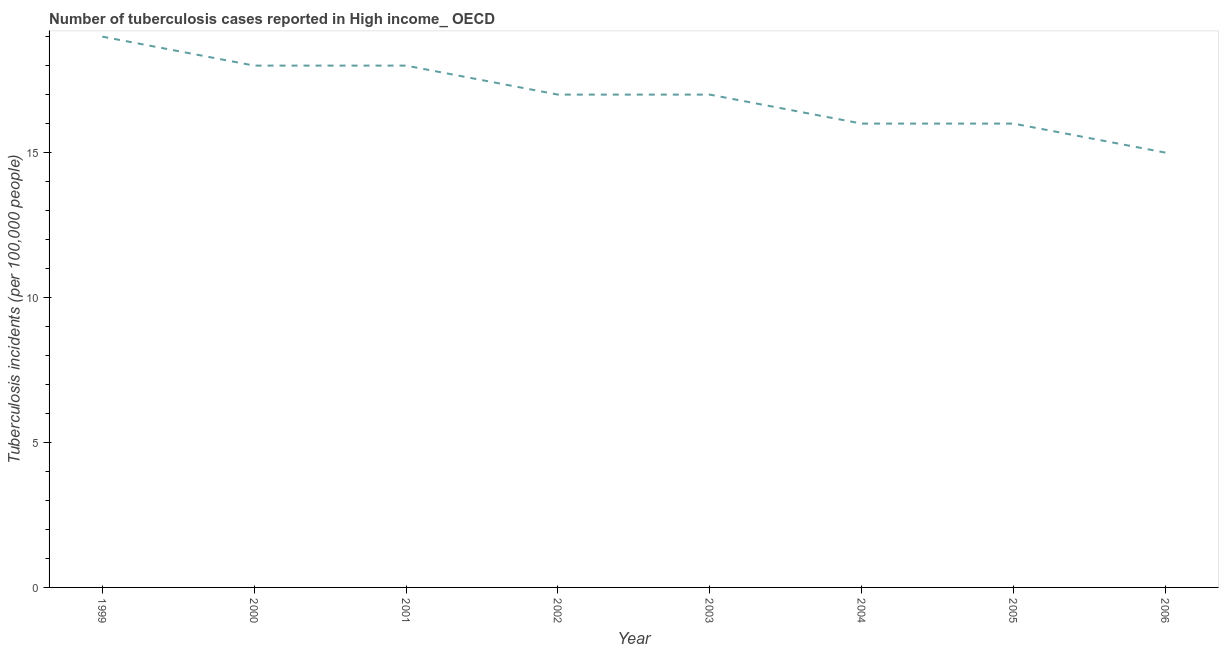What is the number of tuberculosis incidents in 2005?
Keep it short and to the point. 16. Across all years, what is the maximum number of tuberculosis incidents?
Offer a terse response. 19. Across all years, what is the minimum number of tuberculosis incidents?
Offer a very short reply. 15. In which year was the number of tuberculosis incidents maximum?
Make the answer very short. 1999. In which year was the number of tuberculosis incidents minimum?
Give a very brief answer. 2006. What is the sum of the number of tuberculosis incidents?
Offer a very short reply. 136. What is the difference between the number of tuberculosis incidents in 2003 and 2005?
Make the answer very short. 1. Is the difference between the number of tuberculosis incidents in 2004 and 2005 greater than the difference between any two years?
Offer a very short reply. No. What is the difference between the highest and the lowest number of tuberculosis incidents?
Your answer should be very brief. 4. Does the number of tuberculosis incidents monotonically increase over the years?
Provide a succinct answer. No. What is the difference between two consecutive major ticks on the Y-axis?
Make the answer very short. 5. Are the values on the major ticks of Y-axis written in scientific E-notation?
Give a very brief answer. No. Does the graph contain any zero values?
Give a very brief answer. No. What is the title of the graph?
Provide a short and direct response. Number of tuberculosis cases reported in High income_ OECD. What is the label or title of the Y-axis?
Provide a short and direct response. Tuberculosis incidents (per 100,0 people). What is the Tuberculosis incidents (per 100,000 people) in 2002?
Offer a terse response. 17. What is the Tuberculosis incidents (per 100,000 people) of 2003?
Provide a short and direct response. 17. What is the Tuberculosis incidents (per 100,000 people) of 2005?
Provide a succinct answer. 16. What is the difference between the Tuberculosis incidents (per 100,000 people) in 1999 and 2000?
Make the answer very short. 1. What is the difference between the Tuberculosis incidents (per 100,000 people) in 1999 and 2004?
Keep it short and to the point. 3. What is the difference between the Tuberculosis incidents (per 100,000 people) in 1999 and 2005?
Provide a succinct answer. 3. What is the difference between the Tuberculosis incidents (per 100,000 people) in 1999 and 2006?
Give a very brief answer. 4. What is the difference between the Tuberculosis incidents (per 100,000 people) in 2000 and 2001?
Your answer should be very brief. 0. What is the difference between the Tuberculosis incidents (per 100,000 people) in 2000 and 2002?
Ensure brevity in your answer.  1. What is the difference between the Tuberculosis incidents (per 100,000 people) in 2000 and 2003?
Give a very brief answer. 1. What is the difference between the Tuberculosis incidents (per 100,000 people) in 2000 and 2004?
Make the answer very short. 2. What is the difference between the Tuberculosis incidents (per 100,000 people) in 2000 and 2006?
Make the answer very short. 3. What is the difference between the Tuberculosis incidents (per 100,000 people) in 2001 and 2003?
Ensure brevity in your answer.  1. What is the difference between the Tuberculosis incidents (per 100,000 people) in 2001 and 2004?
Offer a terse response. 2. What is the difference between the Tuberculosis incidents (per 100,000 people) in 2001 and 2006?
Your answer should be very brief. 3. What is the difference between the Tuberculosis incidents (per 100,000 people) in 2002 and 2003?
Your answer should be compact. 0. What is the difference between the Tuberculosis incidents (per 100,000 people) in 2002 and 2005?
Ensure brevity in your answer.  1. What is the difference between the Tuberculosis incidents (per 100,000 people) in 2003 and 2005?
Provide a short and direct response. 1. What is the difference between the Tuberculosis incidents (per 100,000 people) in 2003 and 2006?
Make the answer very short. 2. What is the difference between the Tuberculosis incidents (per 100,000 people) in 2004 and 2006?
Make the answer very short. 1. What is the ratio of the Tuberculosis incidents (per 100,000 people) in 1999 to that in 2000?
Your answer should be compact. 1.06. What is the ratio of the Tuberculosis incidents (per 100,000 people) in 1999 to that in 2001?
Your response must be concise. 1.06. What is the ratio of the Tuberculosis incidents (per 100,000 people) in 1999 to that in 2002?
Your response must be concise. 1.12. What is the ratio of the Tuberculosis incidents (per 100,000 people) in 1999 to that in 2003?
Provide a short and direct response. 1.12. What is the ratio of the Tuberculosis incidents (per 100,000 people) in 1999 to that in 2004?
Your response must be concise. 1.19. What is the ratio of the Tuberculosis incidents (per 100,000 people) in 1999 to that in 2005?
Provide a succinct answer. 1.19. What is the ratio of the Tuberculosis incidents (per 100,000 people) in 1999 to that in 2006?
Provide a succinct answer. 1.27. What is the ratio of the Tuberculosis incidents (per 100,000 people) in 2000 to that in 2002?
Provide a short and direct response. 1.06. What is the ratio of the Tuberculosis incidents (per 100,000 people) in 2000 to that in 2003?
Make the answer very short. 1.06. What is the ratio of the Tuberculosis incidents (per 100,000 people) in 2000 to that in 2004?
Ensure brevity in your answer.  1.12. What is the ratio of the Tuberculosis incidents (per 100,000 people) in 2000 to that in 2005?
Your answer should be very brief. 1.12. What is the ratio of the Tuberculosis incidents (per 100,000 people) in 2001 to that in 2002?
Your response must be concise. 1.06. What is the ratio of the Tuberculosis incidents (per 100,000 people) in 2001 to that in 2003?
Your answer should be compact. 1.06. What is the ratio of the Tuberculosis incidents (per 100,000 people) in 2001 to that in 2006?
Keep it short and to the point. 1.2. What is the ratio of the Tuberculosis incidents (per 100,000 people) in 2002 to that in 2004?
Ensure brevity in your answer.  1.06. What is the ratio of the Tuberculosis incidents (per 100,000 people) in 2002 to that in 2005?
Offer a very short reply. 1.06. What is the ratio of the Tuberculosis incidents (per 100,000 people) in 2002 to that in 2006?
Your answer should be compact. 1.13. What is the ratio of the Tuberculosis incidents (per 100,000 people) in 2003 to that in 2004?
Your answer should be very brief. 1.06. What is the ratio of the Tuberculosis incidents (per 100,000 people) in 2003 to that in 2005?
Provide a succinct answer. 1.06. What is the ratio of the Tuberculosis incidents (per 100,000 people) in 2003 to that in 2006?
Give a very brief answer. 1.13. What is the ratio of the Tuberculosis incidents (per 100,000 people) in 2004 to that in 2006?
Give a very brief answer. 1.07. What is the ratio of the Tuberculosis incidents (per 100,000 people) in 2005 to that in 2006?
Your response must be concise. 1.07. 